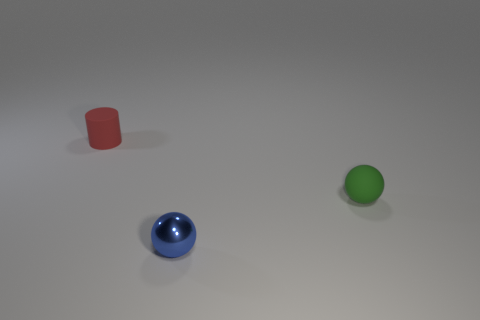Describe the surface upon which the objects are sitting. The objects are resting on a level surface that has a subtle texture, likely indicative of a solid platform within an indoor environment. 